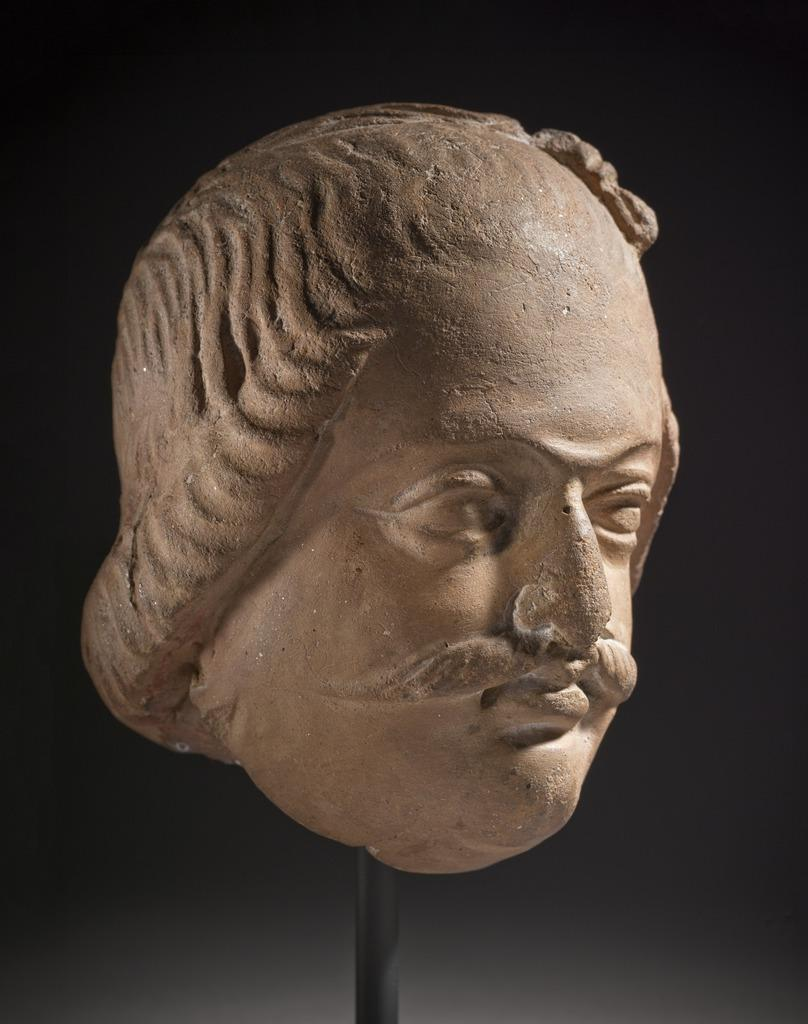What is the main subject of the image? There is a sculpture in the image. Can you describe the background of the image? The background of the image is dark. What type of current can be seen flowing through the sculpture in the image? There is no current flowing through the sculpture in the image, as it is a static object. How does the sculpture react to a cough in the image? There is no cough or any living beings present in the image, so the sculpture cannot react to it. 